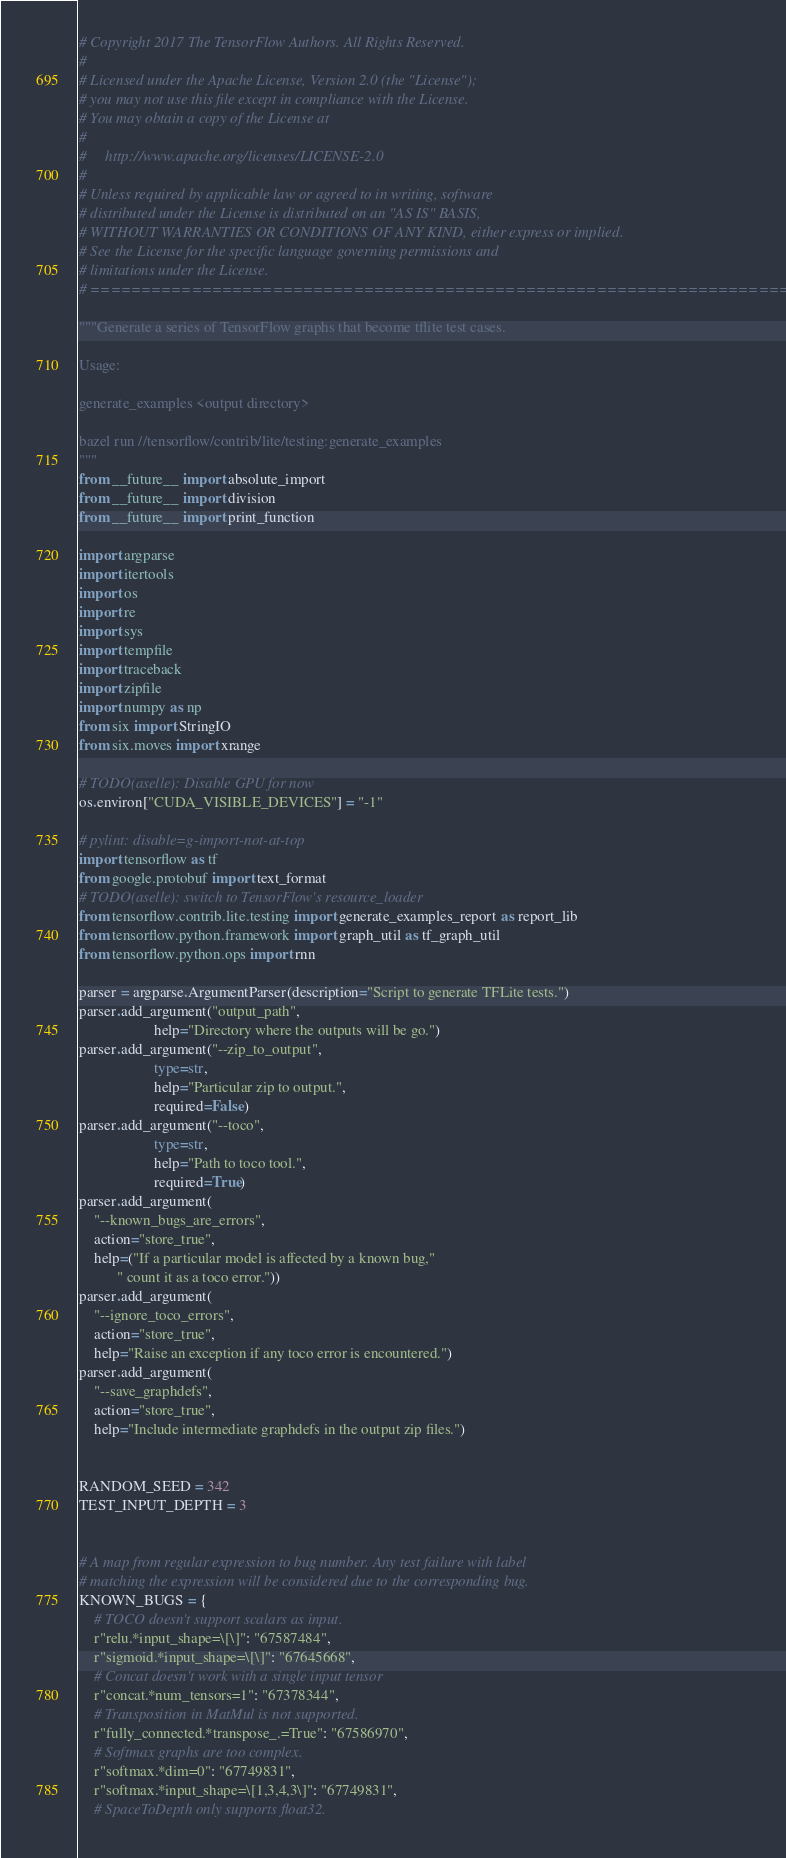<code> <loc_0><loc_0><loc_500><loc_500><_Python_># Copyright 2017 The TensorFlow Authors. All Rights Reserved.
#
# Licensed under the Apache License, Version 2.0 (the "License");
# you may not use this file except in compliance with the License.
# You may obtain a copy of the License at
#
#     http://www.apache.org/licenses/LICENSE-2.0
#
# Unless required by applicable law or agreed to in writing, software
# distributed under the License is distributed on an "AS IS" BASIS,
# WITHOUT WARRANTIES OR CONDITIONS OF ANY KIND, either express or implied.
# See the License for the specific language governing permissions and
# limitations under the License.
# ==============================================================================

"""Generate a series of TensorFlow graphs that become tflite test cases.

Usage:

generate_examples <output directory>

bazel run //tensorflow/contrib/lite/testing:generate_examples
"""
from __future__ import absolute_import
from __future__ import division
from __future__ import print_function

import argparse
import itertools
import os
import re
import sys
import tempfile
import traceback
import zipfile
import numpy as np
from six import StringIO
from six.moves import xrange

# TODO(aselle): Disable GPU for now
os.environ["CUDA_VISIBLE_DEVICES"] = "-1"

# pylint: disable=g-import-not-at-top
import tensorflow as tf
from google.protobuf import text_format
# TODO(aselle): switch to TensorFlow's resource_loader
from tensorflow.contrib.lite.testing import generate_examples_report as report_lib
from tensorflow.python.framework import graph_util as tf_graph_util
from tensorflow.python.ops import rnn

parser = argparse.ArgumentParser(description="Script to generate TFLite tests.")
parser.add_argument("output_path",
                    help="Directory where the outputs will be go.")
parser.add_argument("--zip_to_output",
                    type=str,
                    help="Particular zip to output.",
                    required=False)
parser.add_argument("--toco",
                    type=str,
                    help="Path to toco tool.",
                    required=True)
parser.add_argument(
    "--known_bugs_are_errors",
    action="store_true",
    help=("If a particular model is affected by a known bug,"
          " count it as a toco error."))
parser.add_argument(
    "--ignore_toco_errors",
    action="store_true",
    help="Raise an exception if any toco error is encountered.")
parser.add_argument(
    "--save_graphdefs",
    action="store_true",
    help="Include intermediate graphdefs in the output zip files.")


RANDOM_SEED = 342
TEST_INPUT_DEPTH = 3


# A map from regular expression to bug number. Any test failure with label
# matching the expression will be considered due to the corresponding bug.
KNOWN_BUGS = {
    # TOCO doesn't support scalars as input.
    r"relu.*input_shape=\[\]": "67587484",
    r"sigmoid.*input_shape=\[\]": "67645668",
    # Concat doesn't work with a single input tensor
    r"concat.*num_tensors=1": "67378344",
    # Transposition in MatMul is not supported.
    r"fully_connected.*transpose_.=True": "67586970",
    # Softmax graphs are too complex.
    r"softmax.*dim=0": "67749831",
    r"softmax.*input_shape=\[1,3,4,3\]": "67749831",
    # SpaceToDepth only supports float32.</code> 